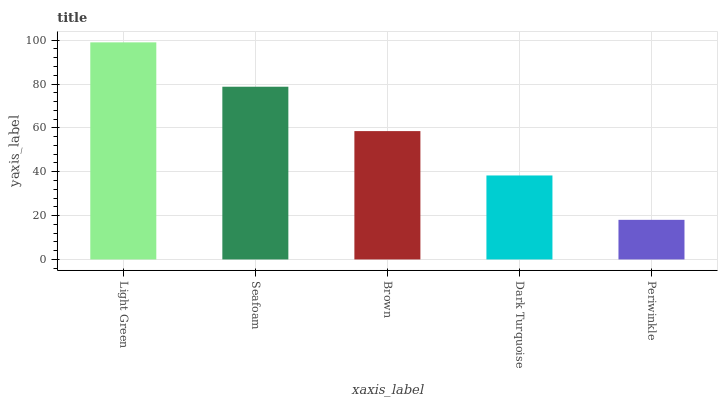Is Periwinkle the minimum?
Answer yes or no. Yes. Is Light Green the maximum?
Answer yes or no. Yes. Is Seafoam the minimum?
Answer yes or no. No. Is Seafoam the maximum?
Answer yes or no. No. Is Light Green greater than Seafoam?
Answer yes or no. Yes. Is Seafoam less than Light Green?
Answer yes or no. Yes. Is Seafoam greater than Light Green?
Answer yes or no. No. Is Light Green less than Seafoam?
Answer yes or no. No. Is Brown the high median?
Answer yes or no. Yes. Is Brown the low median?
Answer yes or no. Yes. Is Dark Turquoise the high median?
Answer yes or no. No. Is Light Green the low median?
Answer yes or no. No. 